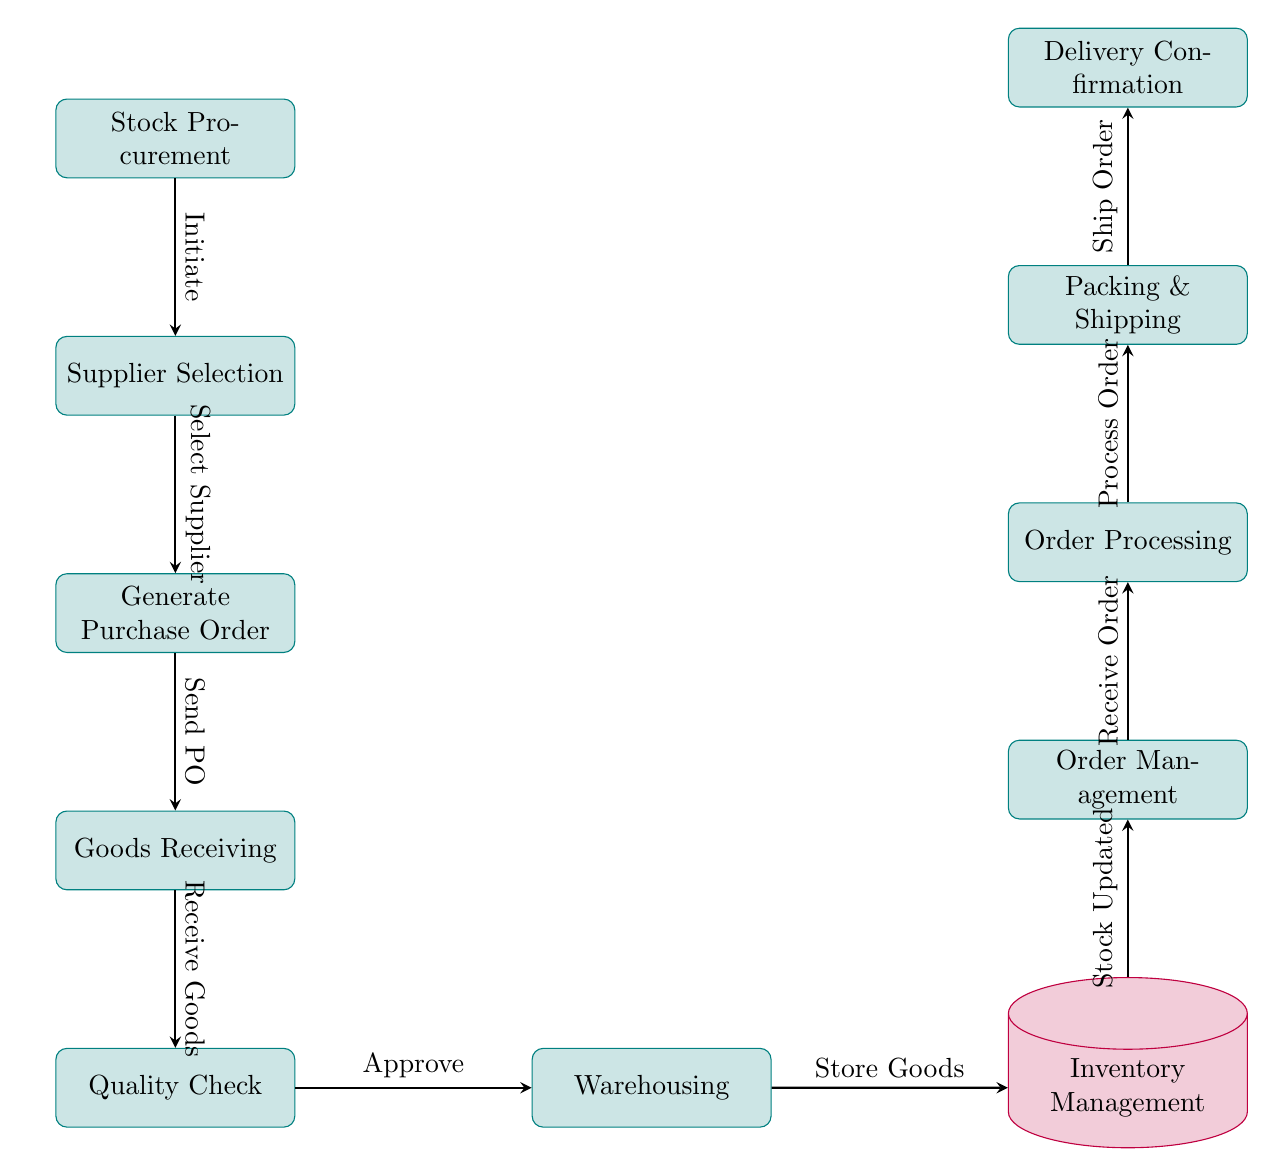What is the first step in the inventory management flowchart? The first step is represented by the node labeled "Stock Procurement." It is the starting point of the process and initiates the flow of steps in the diagram.
Answer: Stock Procurement How many nodes are present in the diagram? Counting all the individual process and storage nodes, there are a total of 11 nodes in the diagram, including "Stock Procurement," "Supplier Selection," "Generate Purchase Order," "Goods Receiving," "Quality Check," "Warehousing," "Inventory Management," "Order Management," "Order Processing," "Packing & Shipping," and "Delivery Confirmation."
Answer: 11 What action is taken after "Quality Check"? The action taken after "Quality Check" is represented by the node "Warehousing." This indicates that once the quality of the goods is checked and approved, they are moved to the warehousing stage.
Answer: Warehousing What is shown to happen before "Packing & Shipping"? Before "Packing & Shipping," the flow shows the reasoning that orders are first processed in the "Order Processing" step. This means that the handling of orders occurs before they are packed and shipped.
Answer: Order Processing Which node immediately follows "Generate Purchase Order"? The node that immediately follows "Generate Purchase Order" is "Goods Receiving." This indicates a sequence where, after generating the purchase order, the next step is to receive the goods that were ordered.
Answer: Goods Receiving How does the inventory management relate to order management in the flowchart? "Inventory Management" is placed directly before "Order Management," which signifies that order management relies on up-to-date inventory information, suggesting that inventory must be updated prior to receiving and processing orders.
Answer: Stock Updated What step is taken after "Packing & Shipping"? After "Packing & Shipping," the next step is "Delivery Confirmation," indicating that once the order is packed and shipped, the final step is to confirm its delivery status.
Answer: Delivery Confirmation What is the purpose of the "Quality Check" node in the flow? The "Quality Check" node serves as an important checkpoint in the flow where goods received are verified for quality. If they do not meet standards, they may not proceed to warehousing. This ensures only quality products are stored and subsequently sold.
Answer: Approve 